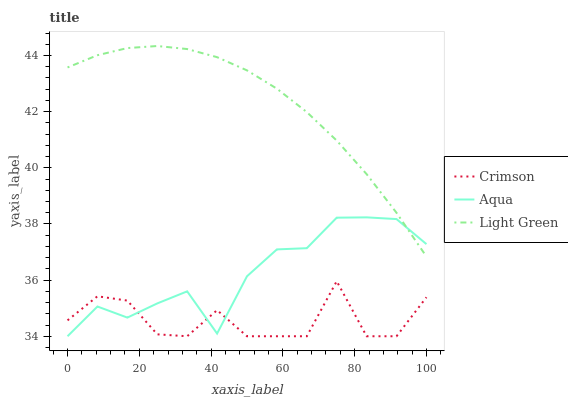Does Crimson have the minimum area under the curve?
Answer yes or no. Yes. Does Light Green have the maximum area under the curve?
Answer yes or no. Yes. Does Aqua have the minimum area under the curve?
Answer yes or no. No. Does Aqua have the maximum area under the curve?
Answer yes or no. No. Is Light Green the smoothest?
Answer yes or no. Yes. Is Crimson the roughest?
Answer yes or no. Yes. Is Aqua the smoothest?
Answer yes or no. No. Is Aqua the roughest?
Answer yes or no. No. Does Crimson have the lowest value?
Answer yes or no. Yes. Does Light Green have the lowest value?
Answer yes or no. No. Does Light Green have the highest value?
Answer yes or no. Yes. Does Aqua have the highest value?
Answer yes or no. No. Is Crimson less than Light Green?
Answer yes or no. Yes. Is Light Green greater than Crimson?
Answer yes or no. Yes. Does Crimson intersect Aqua?
Answer yes or no. Yes. Is Crimson less than Aqua?
Answer yes or no. No. Is Crimson greater than Aqua?
Answer yes or no. No. Does Crimson intersect Light Green?
Answer yes or no. No. 